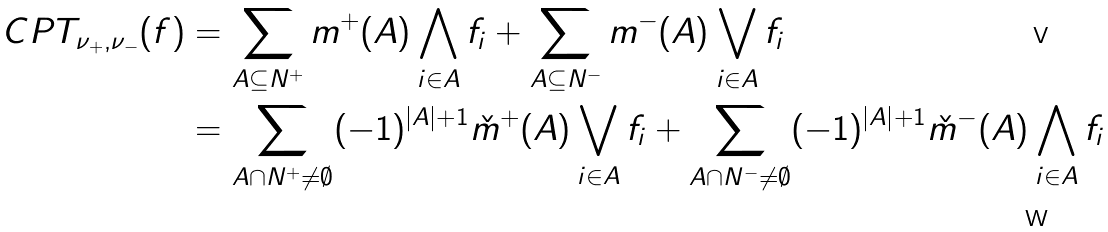Convert formula to latex. <formula><loc_0><loc_0><loc_500><loc_500>C P T _ { \nu _ { + } , \nu _ { - } } ( f ) & = \sum _ { A \subseteq N ^ { + } } m ^ { + } ( A ) \bigwedge _ { i \in A } f _ { i } + \sum _ { A \subseteq N ^ { - } } m ^ { - } ( A ) \bigvee _ { i \in A } f _ { i } \\ & = \sum _ { A \cap N ^ { + } \neq \emptyset } ( - 1 ) ^ { | A | + 1 } \check { m } ^ { + } ( A ) \bigvee _ { i \in A } f _ { i } + \sum _ { A \cap N ^ { - } \neq \emptyset } ( - 1 ) ^ { | A | + 1 } \check { m } ^ { - } ( A ) \bigwedge _ { i \in A } f _ { i }</formula> 